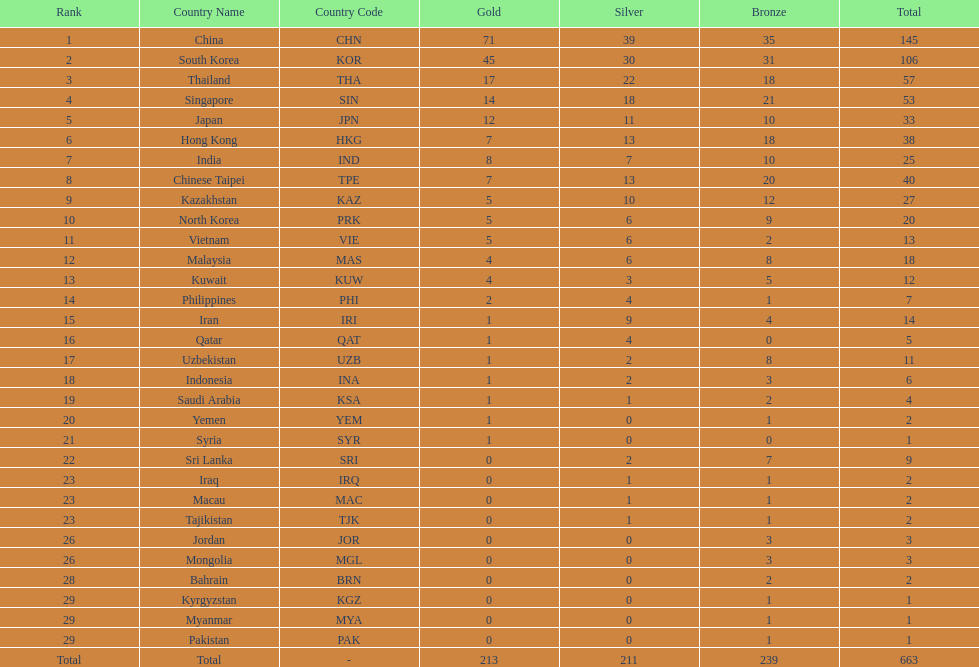Which countries have the same number of silver medals in the asian youth games as north korea? Vietnam (VIE), Malaysia (MAS). 